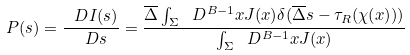<formula> <loc_0><loc_0><loc_500><loc_500>P ( s ) = \frac { \ D I ( s ) } { \ D s } = \frac { \overline { \Delta } \int _ { \Sigma } \ D ^ { B - 1 } x J ( x ) \delta ( \overline { \Delta } s - \tau _ { R } ( \chi ( x ) ) ) } { \int _ { \Sigma } \ D ^ { B - 1 } x J ( x ) }</formula> 